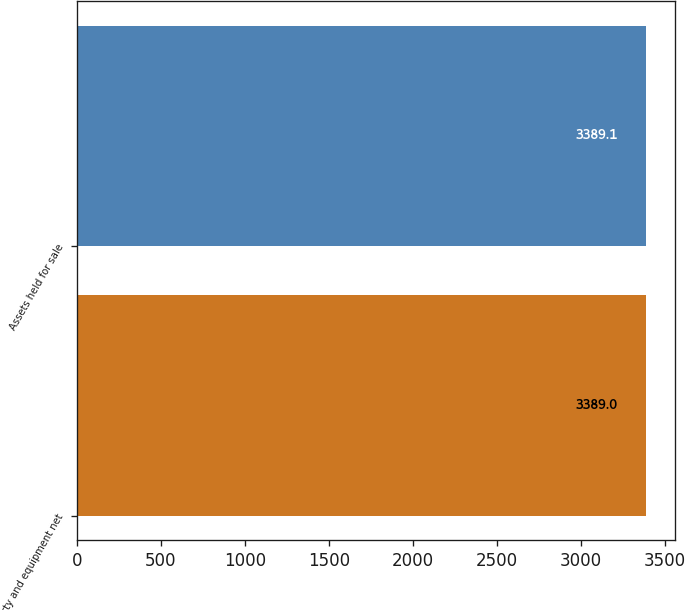<chart> <loc_0><loc_0><loc_500><loc_500><bar_chart><fcel>Property and equipment net<fcel>Assets held for sale<nl><fcel>3389<fcel>3389.1<nl></chart> 